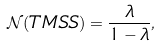<formula> <loc_0><loc_0><loc_500><loc_500>\mathcal { N } ( T M S S ) = \frac { \lambda } { 1 - \lambda } ,</formula> 